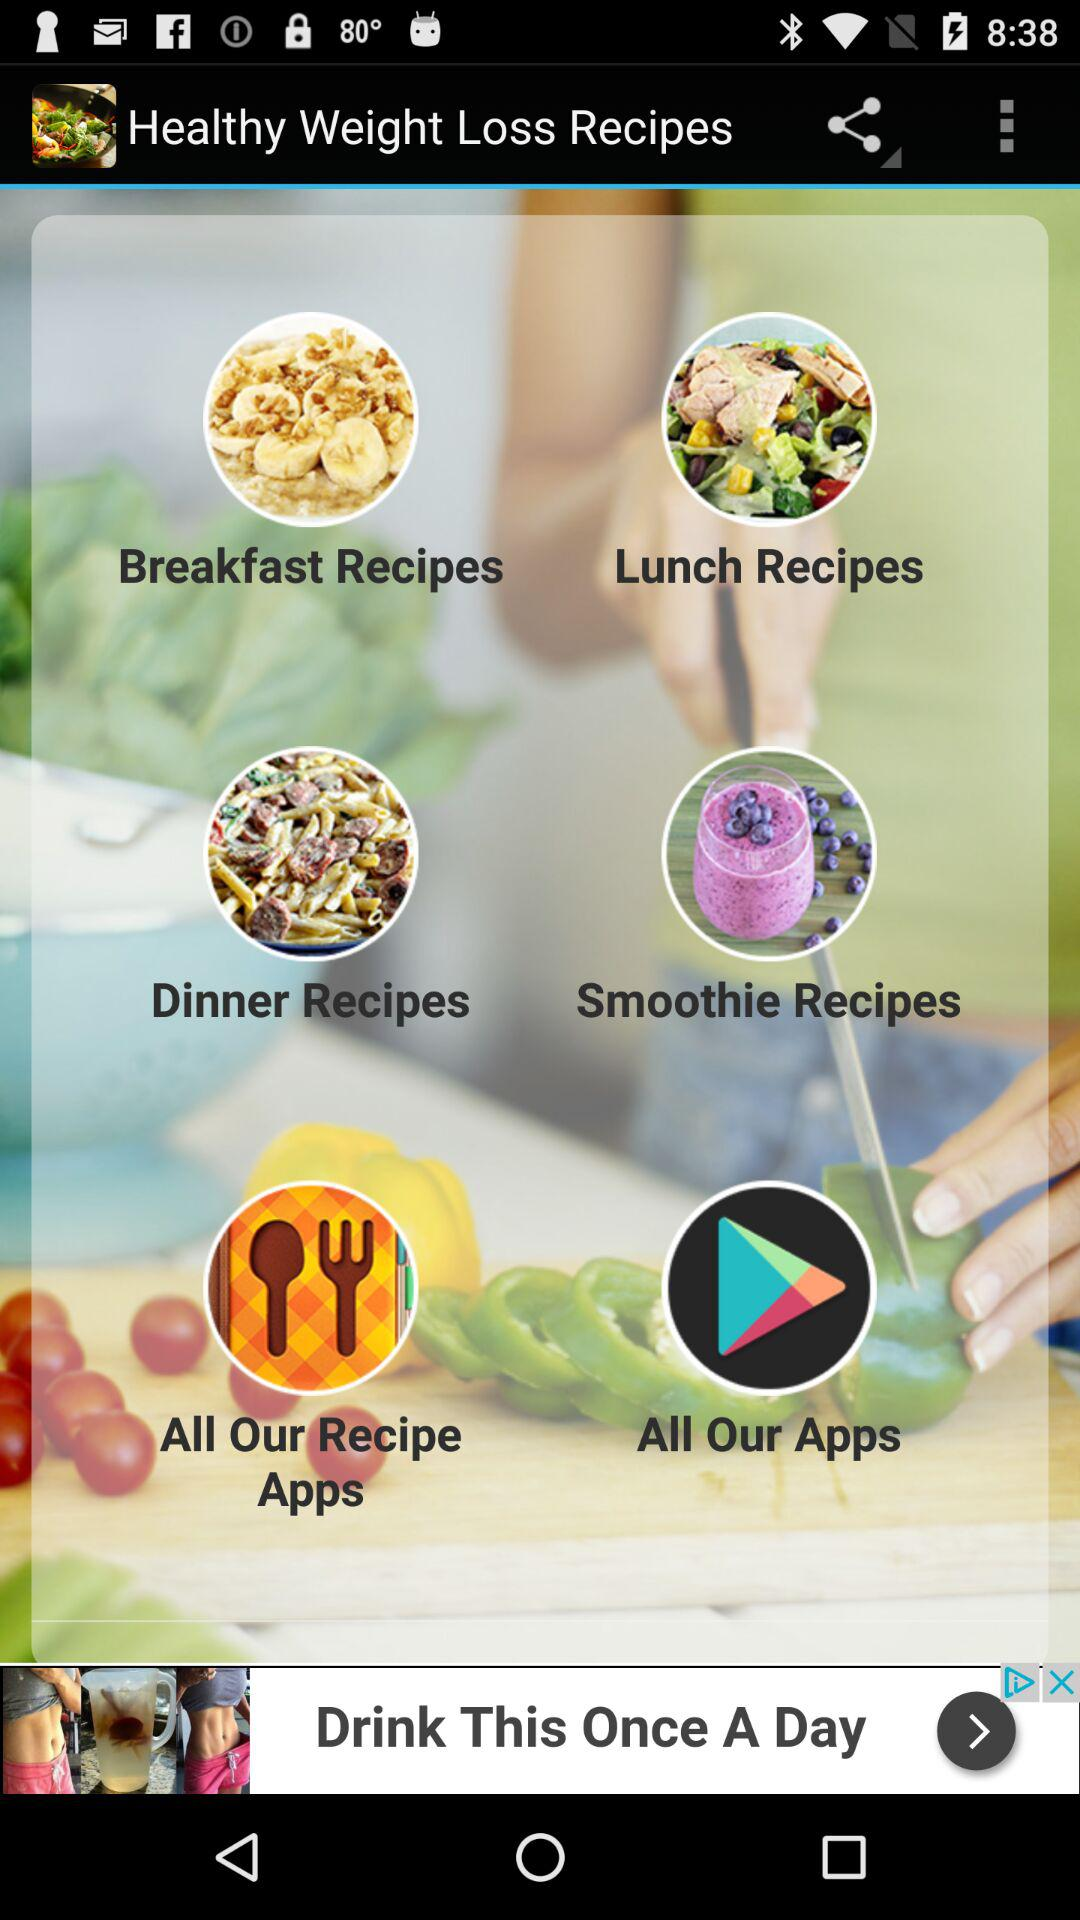How many recipes are there in total?
Answer the question using a single word or phrase. 4 